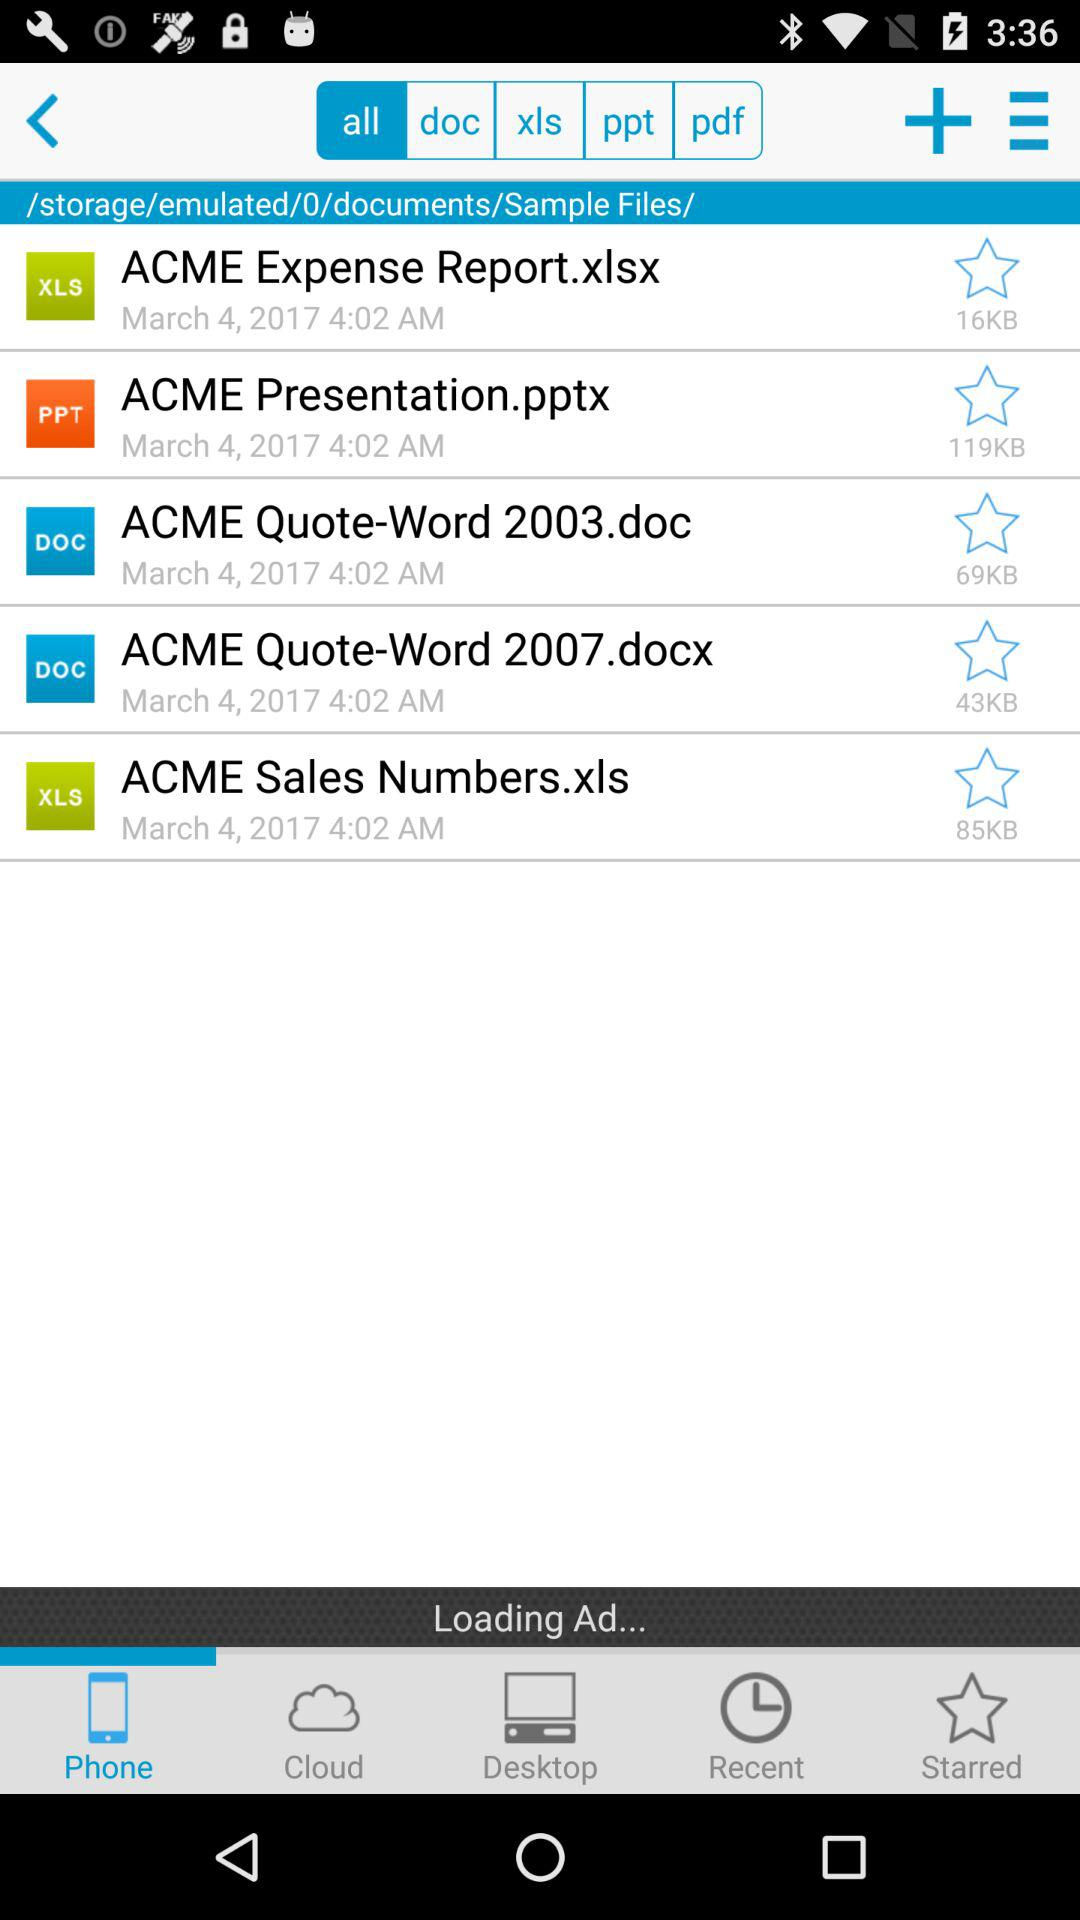Which file was added recently? The files were "ACME Expense Report.xlsx", "ACME Presentation.pptx", "ACME Quote-Word 2003.doc", "ACME Quote-Word 2007.docx" and "ACME Sales Numbers.xls". 